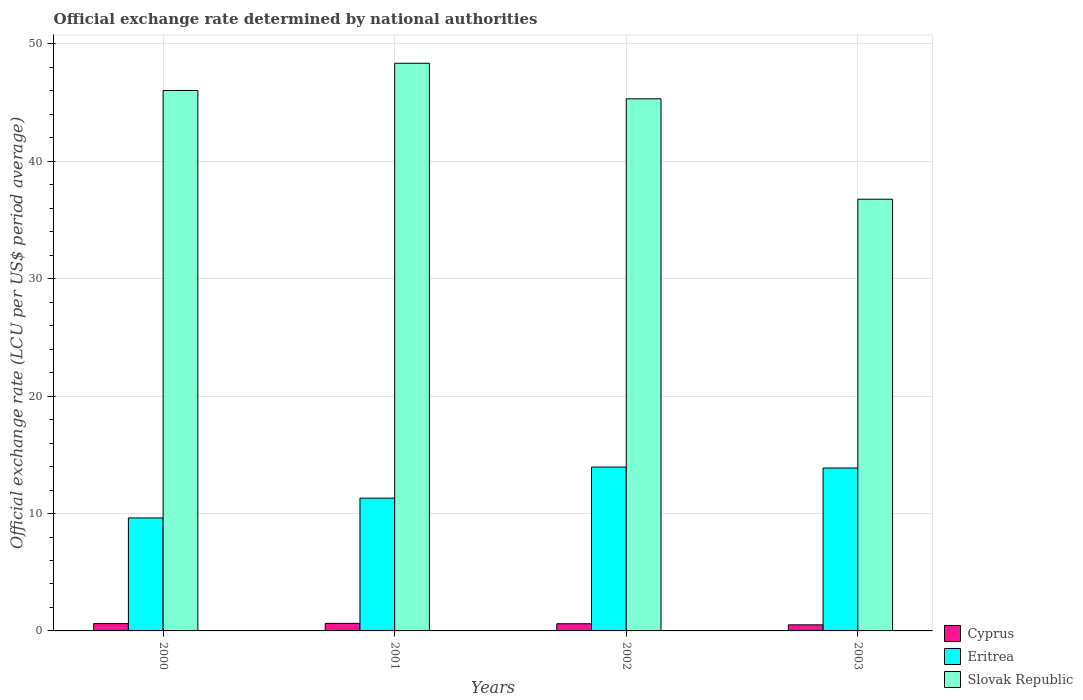How many groups of bars are there?
Your answer should be compact. 4. Are the number of bars on each tick of the X-axis equal?
Give a very brief answer. Yes. In how many cases, is the number of bars for a given year not equal to the number of legend labels?
Your response must be concise. 0. What is the official exchange rate in Cyprus in 2001?
Make the answer very short. 0.64. Across all years, what is the maximum official exchange rate in Cyprus?
Ensure brevity in your answer.  0.64. Across all years, what is the minimum official exchange rate in Cyprus?
Your response must be concise. 0.52. In which year was the official exchange rate in Eritrea minimum?
Ensure brevity in your answer.  2000. What is the total official exchange rate in Eritrea in the graph?
Ensure brevity in your answer.  48.77. What is the difference between the official exchange rate in Eritrea in 2000 and that in 2001?
Your answer should be very brief. -1.68. What is the difference between the official exchange rate in Eritrea in 2000 and the official exchange rate in Slovak Republic in 2001?
Your response must be concise. -38.73. What is the average official exchange rate in Slovak Republic per year?
Your answer should be very brief. 44.12. In the year 2000, what is the difference between the official exchange rate in Cyprus and official exchange rate in Slovak Republic?
Your answer should be very brief. -45.41. In how many years, is the official exchange rate in Eritrea greater than 42 LCU?
Your response must be concise. 0. What is the ratio of the official exchange rate in Eritrea in 2000 to that in 2003?
Give a very brief answer. 0.69. Is the official exchange rate in Eritrea in 2001 less than that in 2003?
Ensure brevity in your answer.  Yes. What is the difference between the highest and the second highest official exchange rate in Cyprus?
Your response must be concise. 0.02. What is the difference between the highest and the lowest official exchange rate in Eritrea?
Your answer should be very brief. 4.33. Is the sum of the official exchange rate in Slovak Republic in 2000 and 2001 greater than the maximum official exchange rate in Eritrea across all years?
Your response must be concise. Yes. What does the 1st bar from the left in 2002 represents?
Provide a succinct answer. Cyprus. What does the 3rd bar from the right in 2003 represents?
Ensure brevity in your answer.  Cyprus. Is it the case that in every year, the sum of the official exchange rate in Cyprus and official exchange rate in Eritrea is greater than the official exchange rate in Slovak Republic?
Offer a terse response. No. How many bars are there?
Ensure brevity in your answer.  12. What is the difference between two consecutive major ticks on the Y-axis?
Your answer should be compact. 10. Are the values on the major ticks of Y-axis written in scientific E-notation?
Provide a short and direct response. No. Does the graph contain grids?
Make the answer very short. Yes. Where does the legend appear in the graph?
Give a very brief answer. Bottom right. What is the title of the graph?
Provide a succinct answer. Official exchange rate determined by national authorities. What is the label or title of the X-axis?
Keep it short and to the point. Years. What is the label or title of the Y-axis?
Ensure brevity in your answer.  Official exchange rate (LCU per US$ period average). What is the Official exchange rate (LCU per US$ period average) of Cyprus in 2000?
Your answer should be very brief. 0.62. What is the Official exchange rate (LCU per US$ period average) of Eritrea in 2000?
Your response must be concise. 9.62. What is the Official exchange rate (LCU per US$ period average) of Slovak Republic in 2000?
Provide a short and direct response. 46.04. What is the Official exchange rate (LCU per US$ period average) in Cyprus in 2001?
Offer a terse response. 0.64. What is the Official exchange rate (LCU per US$ period average) of Eritrea in 2001?
Offer a very short reply. 11.31. What is the Official exchange rate (LCU per US$ period average) in Slovak Republic in 2001?
Offer a terse response. 48.35. What is the Official exchange rate (LCU per US$ period average) of Cyprus in 2002?
Offer a terse response. 0.61. What is the Official exchange rate (LCU per US$ period average) in Eritrea in 2002?
Make the answer very short. 13.96. What is the Official exchange rate (LCU per US$ period average) in Slovak Republic in 2002?
Make the answer very short. 45.33. What is the Official exchange rate (LCU per US$ period average) of Cyprus in 2003?
Make the answer very short. 0.52. What is the Official exchange rate (LCU per US$ period average) of Eritrea in 2003?
Your answer should be very brief. 13.88. What is the Official exchange rate (LCU per US$ period average) in Slovak Republic in 2003?
Your response must be concise. 36.77. Across all years, what is the maximum Official exchange rate (LCU per US$ period average) in Cyprus?
Your answer should be very brief. 0.64. Across all years, what is the maximum Official exchange rate (LCU per US$ period average) of Eritrea?
Provide a succinct answer. 13.96. Across all years, what is the maximum Official exchange rate (LCU per US$ period average) of Slovak Republic?
Keep it short and to the point. 48.35. Across all years, what is the minimum Official exchange rate (LCU per US$ period average) of Cyprus?
Offer a terse response. 0.52. Across all years, what is the minimum Official exchange rate (LCU per US$ period average) of Eritrea?
Your response must be concise. 9.62. Across all years, what is the minimum Official exchange rate (LCU per US$ period average) in Slovak Republic?
Make the answer very short. 36.77. What is the total Official exchange rate (LCU per US$ period average) in Cyprus in the graph?
Make the answer very short. 2.39. What is the total Official exchange rate (LCU per US$ period average) in Eritrea in the graph?
Offer a very short reply. 48.77. What is the total Official exchange rate (LCU per US$ period average) in Slovak Republic in the graph?
Ensure brevity in your answer.  176.49. What is the difference between the Official exchange rate (LCU per US$ period average) of Cyprus in 2000 and that in 2001?
Keep it short and to the point. -0.02. What is the difference between the Official exchange rate (LCU per US$ period average) of Eritrea in 2000 and that in 2001?
Make the answer very short. -1.68. What is the difference between the Official exchange rate (LCU per US$ period average) of Slovak Republic in 2000 and that in 2001?
Your answer should be very brief. -2.32. What is the difference between the Official exchange rate (LCU per US$ period average) of Cyprus in 2000 and that in 2002?
Give a very brief answer. 0.01. What is the difference between the Official exchange rate (LCU per US$ period average) in Eritrea in 2000 and that in 2002?
Make the answer very short. -4.33. What is the difference between the Official exchange rate (LCU per US$ period average) in Slovak Republic in 2000 and that in 2002?
Provide a succinct answer. 0.71. What is the difference between the Official exchange rate (LCU per US$ period average) of Cyprus in 2000 and that in 2003?
Give a very brief answer. 0.1. What is the difference between the Official exchange rate (LCU per US$ period average) of Eritrea in 2000 and that in 2003?
Offer a very short reply. -4.25. What is the difference between the Official exchange rate (LCU per US$ period average) of Slovak Republic in 2000 and that in 2003?
Offer a very short reply. 9.26. What is the difference between the Official exchange rate (LCU per US$ period average) in Cyprus in 2001 and that in 2002?
Offer a terse response. 0.03. What is the difference between the Official exchange rate (LCU per US$ period average) in Eritrea in 2001 and that in 2002?
Your answer should be very brief. -2.65. What is the difference between the Official exchange rate (LCU per US$ period average) in Slovak Republic in 2001 and that in 2002?
Provide a short and direct response. 3.03. What is the difference between the Official exchange rate (LCU per US$ period average) of Cyprus in 2001 and that in 2003?
Offer a very short reply. 0.13. What is the difference between the Official exchange rate (LCU per US$ period average) of Eritrea in 2001 and that in 2003?
Your answer should be very brief. -2.57. What is the difference between the Official exchange rate (LCU per US$ period average) of Slovak Republic in 2001 and that in 2003?
Your answer should be very brief. 11.58. What is the difference between the Official exchange rate (LCU per US$ period average) of Cyprus in 2002 and that in 2003?
Ensure brevity in your answer.  0.09. What is the difference between the Official exchange rate (LCU per US$ period average) of Eritrea in 2002 and that in 2003?
Your answer should be compact. 0.08. What is the difference between the Official exchange rate (LCU per US$ period average) of Slovak Republic in 2002 and that in 2003?
Your answer should be very brief. 8.55. What is the difference between the Official exchange rate (LCU per US$ period average) of Cyprus in 2000 and the Official exchange rate (LCU per US$ period average) of Eritrea in 2001?
Your response must be concise. -10.69. What is the difference between the Official exchange rate (LCU per US$ period average) of Cyprus in 2000 and the Official exchange rate (LCU per US$ period average) of Slovak Republic in 2001?
Offer a very short reply. -47.73. What is the difference between the Official exchange rate (LCU per US$ period average) in Eritrea in 2000 and the Official exchange rate (LCU per US$ period average) in Slovak Republic in 2001?
Ensure brevity in your answer.  -38.73. What is the difference between the Official exchange rate (LCU per US$ period average) of Cyprus in 2000 and the Official exchange rate (LCU per US$ period average) of Eritrea in 2002?
Ensure brevity in your answer.  -13.34. What is the difference between the Official exchange rate (LCU per US$ period average) in Cyprus in 2000 and the Official exchange rate (LCU per US$ period average) in Slovak Republic in 2002?
Your response must be concise. -44.7. What is the difference between the Official exchange rate (LCU per US$ period average) of Eritrea in 2000 and the Official exchange rate (LCU per US$ period average) of Slovak Republic in 2002?
Offer a terse response. -35.7. What is the difference between the Official exchange rate (LCU per US$ period average) in Cyprus in 2000 and the Official exchange rate (LCU per US$ period average) in Eritrea in 2003?
Your response must be concise. -13.26. What is the difference between the Official exchange rate (LCU per US$ period average) of Cyprus in 2000 and the Official exchange rate (LCU per US$ period average) of Slovak Republic in 2003?
Your response must be concise. -36.15. What is the difference between the Official exchange rate (LCU per US$ period average) of Eritrea in 2000 and the Official exchange rate (LCU per US$ period average) of Slovak Republic in 2003?
Make the answer very short. -27.15. What is the difference between the Official exchange rate (LCU per US$ period average) in Cyprus in 2001 and the Official exchange rate (LCU per US$ period average) in Eritrea in 2002?
Your answer should be very brief. -13.32. What is the difference between the Official exchange rate (LCU per US$ period average) of Cyprus in 2001 and the Official exchange rate (LCU per US$ period average) of Slovak Republic in 2002?
Give a very brief answer. -44.68. What is the difference between the Official exchange rate (LCU per US$ period average) of Eritrea in 2001 and the Official exchange rate (LCU per US$ period average) of Slovak Republic in 2002?
Give a very brief answer. -34.02. What is the difference between the Official exchange rate (LCU per US$ period average) in Cyprus in 2001 and the Official exchange rate (LCU per US$ period average) in Eritrea in 2003?
Offer a very short reply. -13.23. What is the difference between the Official exchange rate (LCU per US$ period average) in Cyprus in 2001 and the Official exchange rate (LCU per US$ period average) in Slovak Republic in 2003?
Give a very brief answer. -36.13. What is the difference between the Official exchange rate (LCU per US$ period average) of Eritrea in 2001 and the Official exchange rate (LCU per US$ period average) of Slovak Republic in 2003?
Offer a terse response. -25.46. What is the difference between the Official exchange rate (LCU per US$ period average) in Cyprus in 2002 and the Official exchange rate (LCU per US$ period average) in Eritrea in 2003?
Your response must be concise. -13.27. What is the difference between the Official exchange rate (LCU per US$ period average) in Cyprus in 2002 and the Official exchange rate (LCU per US$ period average) in Slovak Republic in 2003?
Offer a terse response. -36.16. What is the difference between the Official exchange rate (LCU per US$ period average) of Eritrea in 2002 and the Official exchange rate (LCU per US$ period average) of Slovak Republic in 2003?
Offer a terse response. -22.81. What is the average Official exchange rate (LCU per US$ period average) of Cyprus per year?
Provide a short and direct response. 0.6. What is the average Official exchange rate (LCU per US$ period average) of Eritrea per year?
Give a very brief answer. 12.19. What is the average Official exchange rate (LCU per US$ period average) in Slovak Republic per year?
Make the answer very short. 44.12. In the year 2000, what is the difference between the Official exchange rate (LCU per US$ period average) of Cyprus and Official exchange rate (LCU per US$ period average) of Eritrea?
Offer a very short reply. -9. In the year 2000, what is the difference between the Official exchange rate (LCU per US$ period average) of Cyprus and Official exchange rate (LCU per US$ period average) of Slovak Republic?
Provide a succinct answer. -45.41. In the year 2000, what is the difference between the Official exchange rate (LCU per US$ period average) in Eritrea and Official exchange rate (LCU per US$ period average) in Slovak Republic?
Offer a terse response. -36.41. In the year 2001, what is the difference between the Official exchange rate (LCU per US$ period average) of Cyprus and Official exchange rate (LCU per US$ period average) of Eritrea?
Your answer should be compact. -10.67. In the year 2001, what is the difference between the Official exchange rate (LCU per US$ period average) of Cyprus and Official exchange rate (LCU per US$ period average) of Slovak Republic?
Your answer should be very brief. -47.71. In the year 2001, what is the difference between the Official exchange rate (LCU per US$ period average) in Eritrea and Official exchange rate (LCU per US$ period average) in Slovak Republic?
Keep it short and to the point. -37.05. In the year 2002, what is the difference between the Official exchange rate (LCU per US$ period average) of Cyprus and Official exchange rate (LCU per US$ period average) of Eritrea?
Provide a short and direct response. -13.35. In the year 2002, what is the difference between the Official exchange rate (LCU per US$ period average) in Cyprus and Official exchange rate (LCU per US$ period average) in Slovak Republic?
Keep it short and to the point. -44.72. In the year 2002, what is the difference between the Official exchange rate (LCU per US$ period average) in Eritrea and Official exchange rate (LCU per US$ period average) in Slovak Republic?
Offer a terse response. -31.37. In the year 2003, what is the difference between the Official exchange rate (LCU per US$ period average) in Cyprus and Official exchange rate (LCU per US$ period average) in Eritrea?
Your response must be concise. -13.36. In the year 2003, what is the difference between the Official exchange rate (LCU per US$ period average) in Cyprus and Official exchange rate (LCU per US$ period average) in Slovak Republic?
Give a very brief answer. -36.26. In the year 2003, what is the difference between the Official exchange rate (LCU per US$ period average) of Eritrea and Official exchange rate (LCU per US$ period average) of Slovak Republic?
Ensure brevity in your answer.  -22.89. What is the ratio of the Official exchange rate (LCU per US$ period average) in Cyprus in 2000 to that in 2001?
Offer a terse response. 0.97. What is the ratio of the Official exchange rate (LCU per US$ period average) in Eritrea in 2000 to that in 2001?
Offer a very short reply. 0.85. What is the ratio of the Official exchange rate (LCU per US$ period average) of Slovak Republic in 2000 to that in 2001?
Your answer should be very brief. 0.95. What is the ratio of the Official exchange rate (LCU per US$ period average) of Cyprus in 2000 to that in 2002?
Your answer should be very brief. 1.02. What is the ratio of the Official exchange rate (LCU per US$ period average) in Eritrea in 2000 to that in 2002?
Provide a succinct answer. 0.69. What is the ratio of the Official exchange rate (LCU per US$ period average) of Slovak Republic in 2000 to that in 2002?
Your response must be concise. 1.02. What is the ratio of the Official exchange rate (LCU per US$ period average) in Cyprus in 2000 to that in 2003?
Ensure brevity in your answer.  1.2. What is the ratio of the Official exchange rate (LCU per US$ period average) in Eritrea in 2000 to that in 2003?
Keep it short and to the point. 0.69. What is the ratio of the Official exchange rate (LCU per US$ period average) of Slovak Republic in 2000 to that in 2003?
Offer a very short reply. 1.25. What is the ratio of the Official exchange rate (LCU per US$ period average) of Cyprus in 2001 to that in 2002?
Ensure brevity in your answer.  1.05. What is the ratio of the Official exchange rate (LCU per US$ period average) in Eritrea in 2001 to that in 2002?
Your answer should be very brief. 0.81. What is the ratio of the Official exchange rate (LCU per US$ period average) of Slovak Republic in 2001 to that in 2002?
Provide a succinct answer. 1.07. What is the ratio of the Official exchange rate (LCU per US$ period average) of Cyprus in 2001 to that in 2003?
Keep it short and to the point. 1.24. What is the ratio of the Official exchange rate (LCU per US$ period average) in Eritrea in 2001 to that in 2003?
Offer a terse response. 0.81. What is the ratio of the Official exchange rate (LCU per US$ period average) in Slovak Republic in 2001 to that in 2003?
Provide a short and direct response. 1.31. What is the ratio of the Official exchange rate (LCU per US$ period average) of Cyprus in 2002 to that in 2003?
Keep it short and to the point. 1.18. What is the ratio of the Official exchange rate (LCU per US$ period average) in Eritrea in 2002 to that in 2003?
Offer a very short reply. 1.01. What is the ratio of the Official exchange rate (LCU per US$ period average) of Slovak Republic in 2002 to that in 2003?
Ensure brevity in your answer.  1.23. What is the difference between the highest and the second highest Official exchange rate (LCU per US$ period average) in Cyprus?
Ensure brevity in your answer.  0.02. What is the difference between the highest and the second highest Official exchange rate (LCU per US$ period average) in Eritrea?
Give a very brief answer. 0.08. What is the difference between the highest and the second highest Official exchange rate (LCU per US$ period average) of Slovak Republic?
Keep it short and to the point. 2.32. What is the difference between the highest and the lowest Official exchange rate (LCU per US$ period average) of Cyprus?
Offer a terse response. 0.13. What is the difference between the highest and the lowest Official exchange rate (LCU per US$ period average) of Eritrea?
Your answer should be very brief. 4.33. What is the difference between the highest and the lowest Official exchange rate (LCU per US$ period average) in Slovak Republic?
Keep it short and to the point. 11.58. 